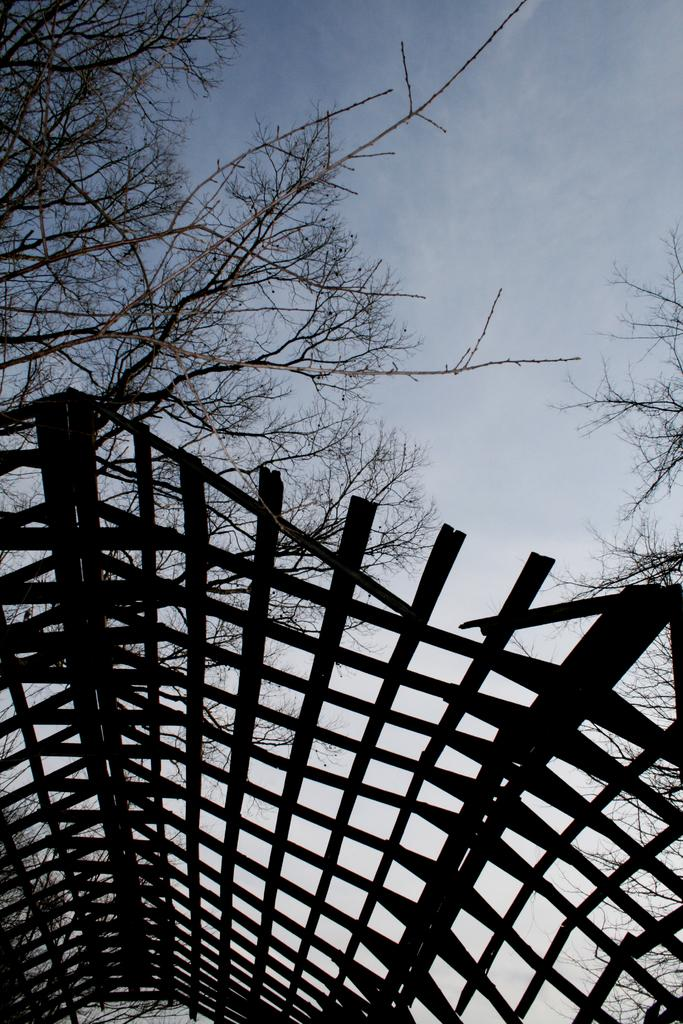What type of structure is present in the image? There is a shelter in the image. What feature does the shelter have? The shelter has a roof. What type of natural environment can be seen in the image? Trees are visible in the image. What is visible in the background of the image? The sky is visible in the background of the image. What type of division can be seen in the image? There is no division present in the image; it features a shelter with a roof, trees, and the sky. Can you spot a toad in the image? There is no toad present in the image. 